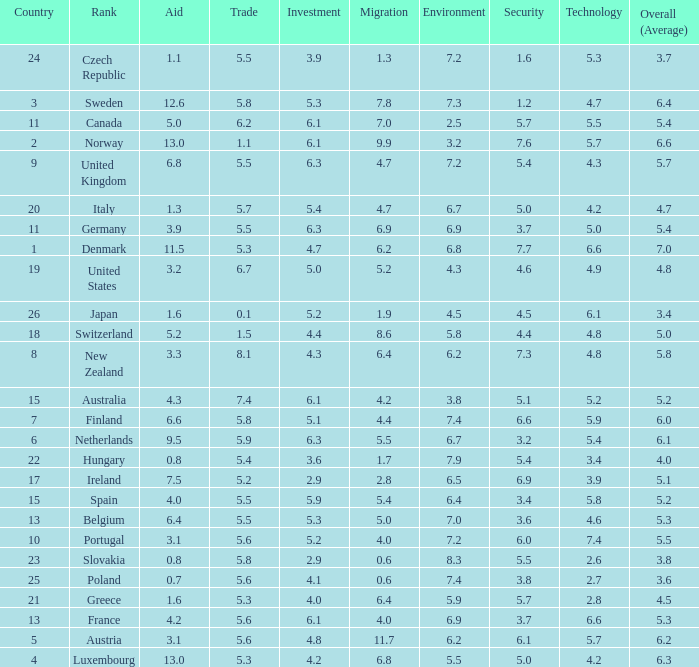What is the environment rating of the country with an overall average rating of 4.7? 6.7. 